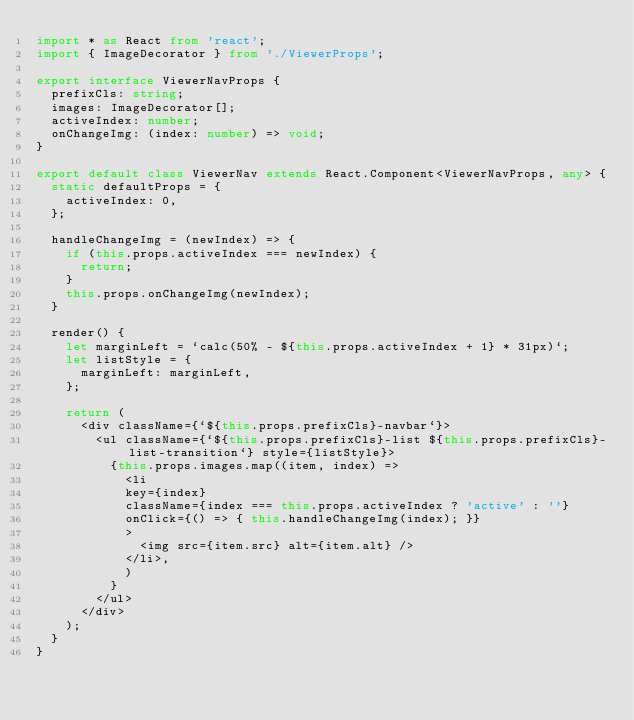Convert code to text. <code><loc_0><loc_0><loc_500><loc_500><_TypeScript_>import * as React from 'react';
import { ImageDecorator } from './ViewerProps';

export interface ViewerNavProps {
  prefixCls: string;
  images: ImageDecorator[];
  activeIndex: number;
  onChangeImg: (index: number) => void;
}

export default class ViewerNav extends React.Component<ViewerNavProps, any> {
  static defaultProps = {
    activeIndex: 0,
  };

  handleChangeImg = (newIndex) => {
    if (this.props.activeIndex === newIndex) {
      return;
    }
    this.props.onChangeImg(newIndex);
  }

  render() {
    let marginLeft = `calc(50% - ${this.props.activeIndex + 1} * 31px)`;
    let listStyle = {
      marginLeft: marginLeft,
    };

    return (
      <div className={`${this.props.prefixCls}-navbar`}>
        <ul className={`${this.props.prefixCls}-list ${this.props.prefixCls}-list-transition`} style={listStyle}>
          {this.props.images.map((item, index) =>
            <li
            key={index}
            className={index === this.props.activeIndex ? 'active' : ''}
            onClick={() => { this.handleChangeImg(index); }}
            >
              <img src={item.src} alt={item.alt} />
            </li>,
            )
          }
        </ul>
      </div>
    );
  }
}
</code> 